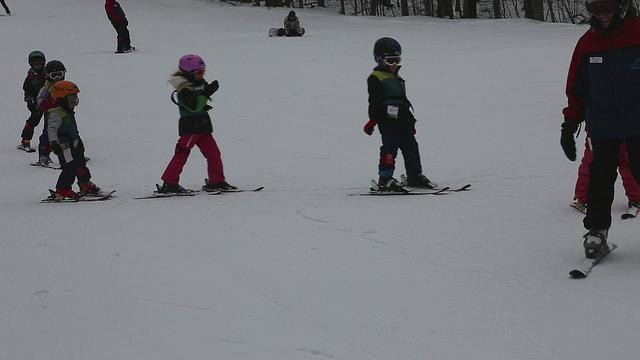How many people are there?
Give a very brief answer. 9. How many people can be seen in this picture?
Give a very brief answer. 8. How many children are wearing helmets?
Give a very brief answer. 5. How many skiers are visible?
Give a very brief answer. 8. How many people in this photo?
Give a very brief answer. 9. How many people are wearing skis?
Give a very brief answer. 7. How many people are visible?
Give a very brief answer. 4. How many of the zebras are standing up?
Give a very brief answer. 0. 